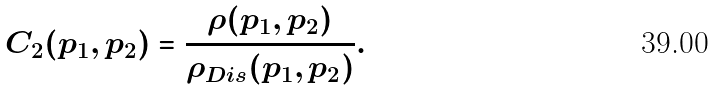Convert formula to latex. <formula><loc_0><loc_0><loc_500><loc_500>C _ { 2 } ( { p _ { 1 } , p _ { 2 } } ) = \frac { \rho ( { p _ { 1 } , p _ { 2 } } ) } { \rho _ { D i s } ( { p _ { 1 } , p _ { 2 } } ) } .</formula> 